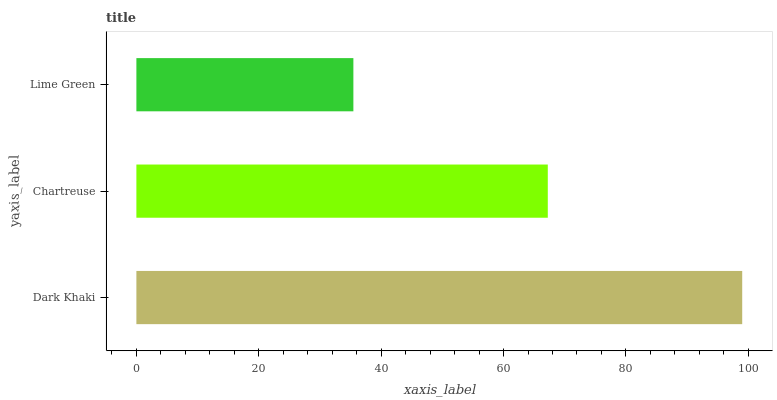Is Lime Green the minimum?
Answer yes or no. Yes. Is Dark Khaki the maximum?
Answer yes or no. Yes. Is Chartreuse the minimum?
Answer yes or no. No. Is Chartreuse the maximum?
Answer yes or no. No. Is Dark Khaki greater than Chartreuse?
Answer yes or no. Yes. Is Chartreuse less than Dark Khaki?
Answer yes or no. Yes. Is Chartreuse greater than Dark Khaki?
Answer yes or no. No. Is Dark Khaki less than Chartreuse?
Answer yes or no. No. Is Chartreuse the high median?
Answer yes or no. Yes. Is Chartreuse the low median?
Answer yes or no. Yes. Is Dark Khaki the high median?
Answer yes or no. No. Is Lime Green the low median?
Answer yes or no. No. 